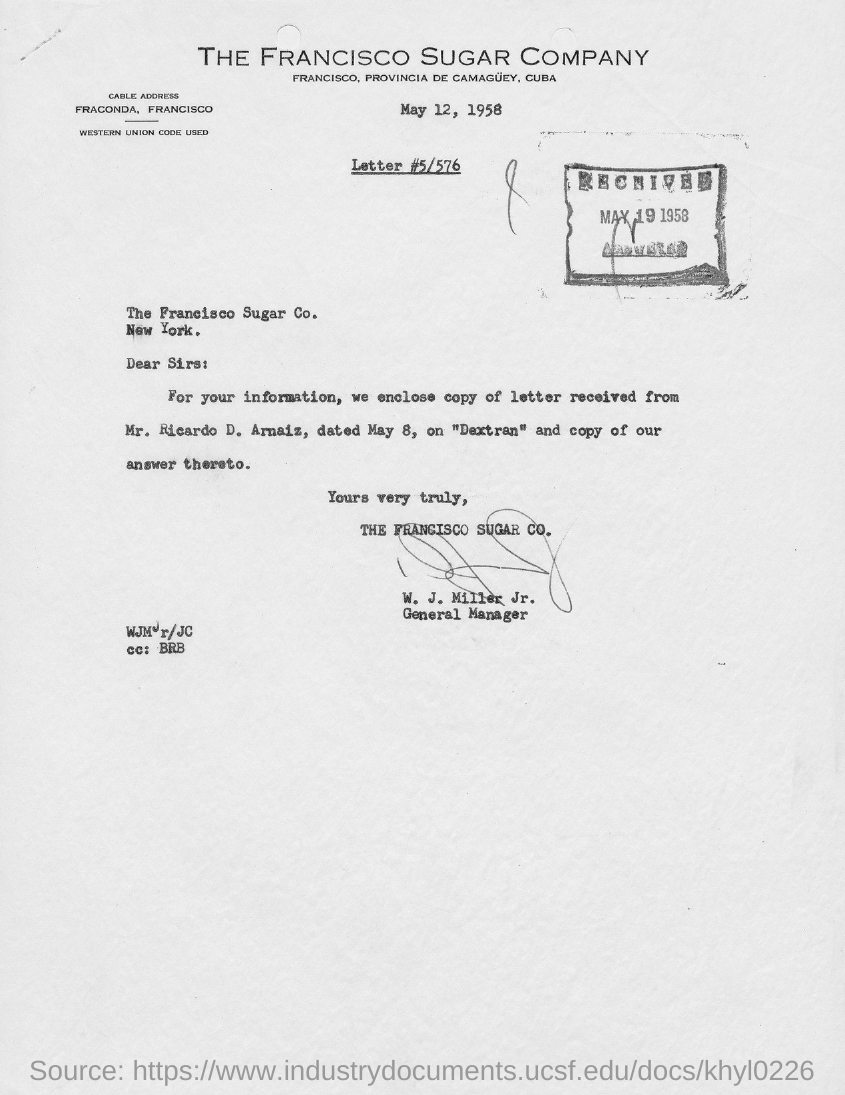Which company is mentioned in the letterhead?
Offer a very short reply. THE FRANCISCO SUGAR COMPANY. What is the issued date of this letter?
Keep it short and to the point. May 12, 1958. What is the letter  #(no) given?
Keep it short and to the point. 5/576. Who has signed this letter?
Ensure brevity in your answer.  W. J. Miller, Jr. What is the designation of W. J. Miller, Jr.?
Ensure brevity in your answer.  General Manager. What is the cable address given in the letter?
Your answer should be very brief. FRACONDA, FRANCISCO. What is the received date of this letter?
Ensure brevity in your answer.  MAY 19 1958. Who is marked in the cc of this letter?
Your answer should be very brief. BRB. 